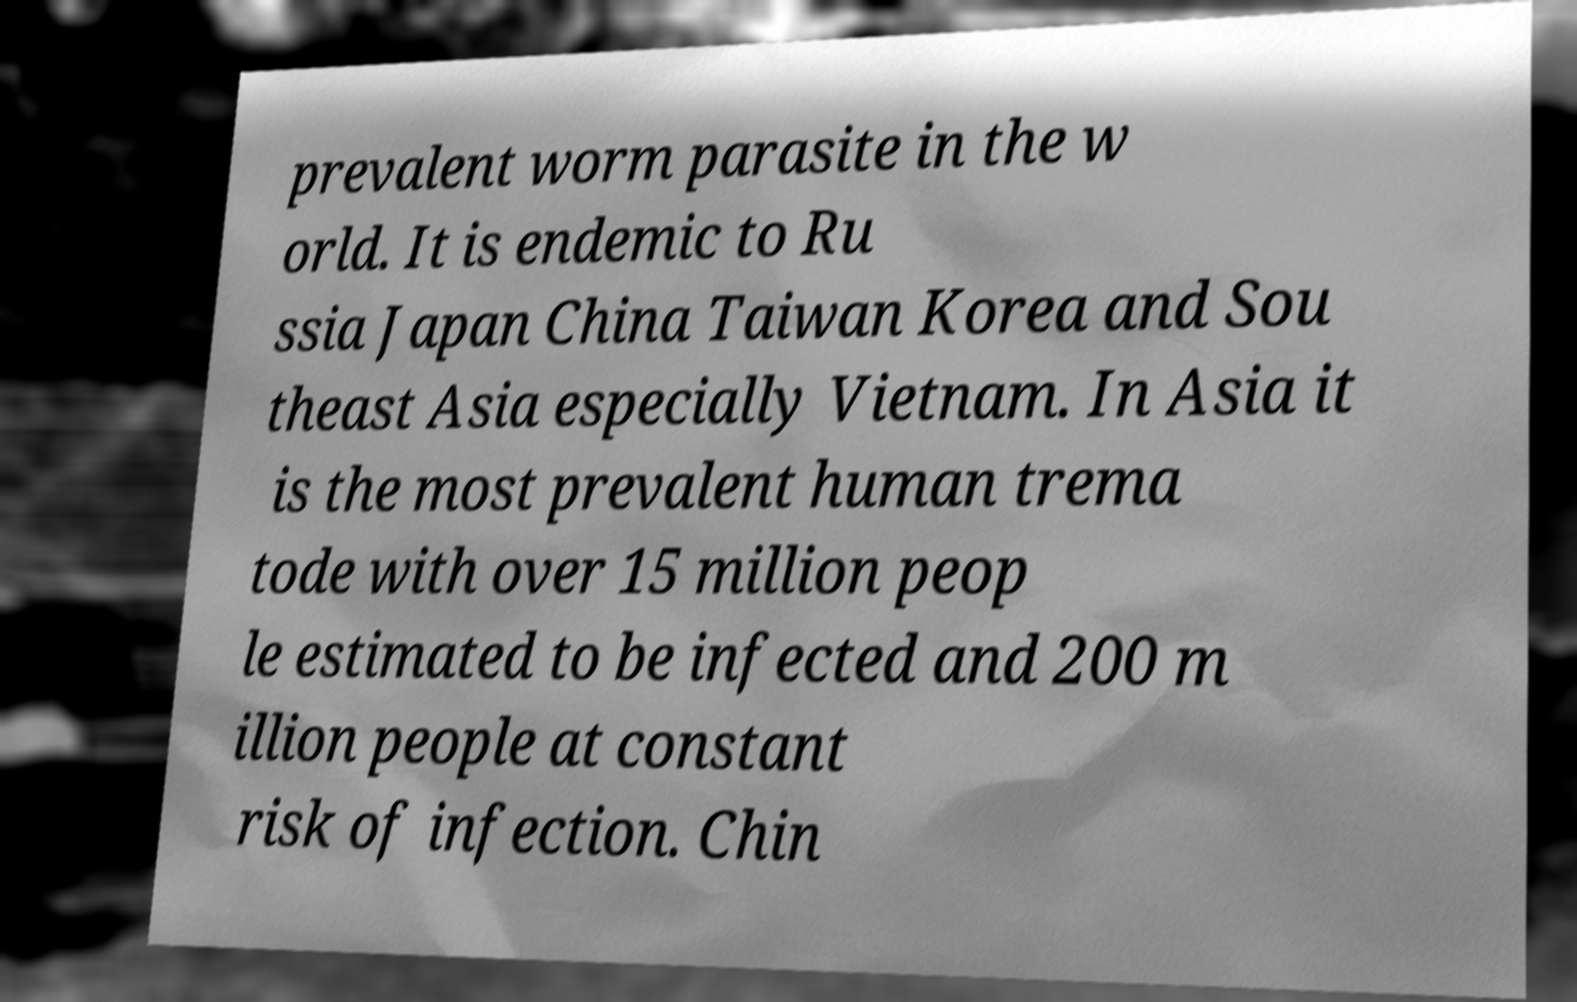For documentation purposes, I need the text within this image transcribed. Could you provide that? prevalent worm parasite in the w orld. It is endemic to Ru ssia Japan China Taiwan Korea and Sou theast Asia especially Vietnam. In Asia it is the most prevalent human trema tode with over 15 million peop le estimated to be infected and 200 m illion people at constant risk of infection. Chin 